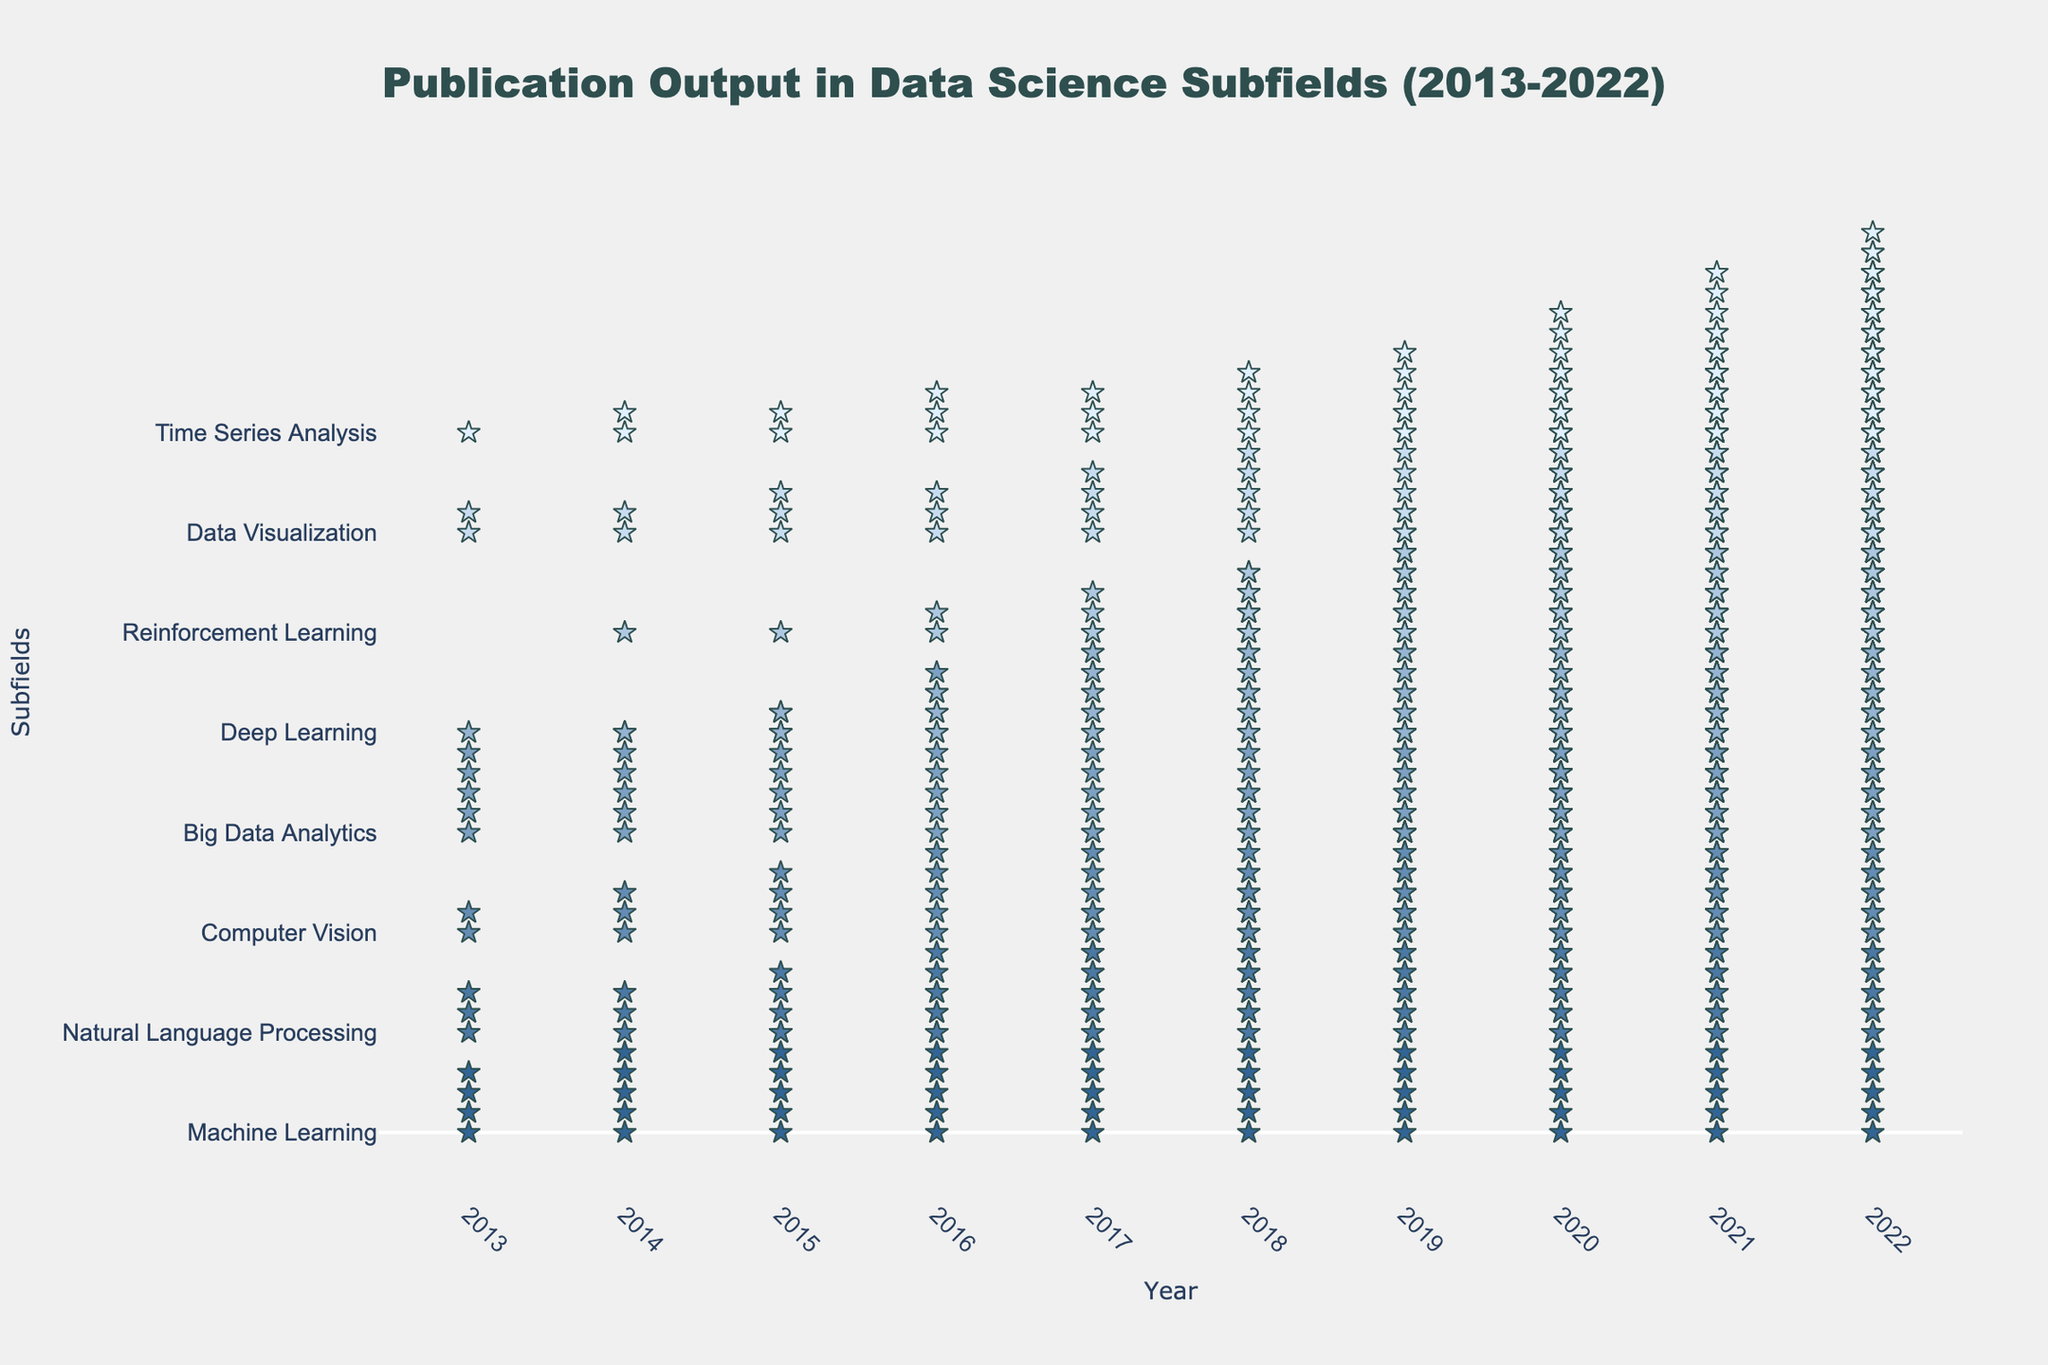What year had the highest publication output for Machine Learning? The figure shows stars representing the number of publications each year. Machine Learning has the most stars in 2022, indicating the highest number of publications.
Answer: 2022 Between 2018 and 2020, which subfield had the largest increase in publication output? By counting the stars for each subfield between 2018 and 2020, we see that Deep Learning has the highest increase in the number of stars from 35 to 70 publications, a 35 publication increase.
Answer: Deep Learning Which subfield had more publications in 2017: Natural Language Processing or Computer Vision? In 2017, count the stars for both subfields. Natural Language Processing has 7 stars (35 publications), and Computer Vision has 6 stars (32 publications).
Answer: Natural Language Processing What is the total number of subfields represented in the plot? The y-axis lists the subfields. Count each unique name listed on the y-axis.
Answer: 8 Between Big Data Analytics and Machine Learning, which subfield had fewer publications in 2015? Compare the number of stars for both subfields in 2015. Big Data Analytics has 7 stars (35 publications), and Machine Learning has 6 stars (30 publications).
Answer: Machine Learning Which subfield shows the steepest growth in publication output over the first 3 years (2013-2015)? Calculate the difference in the number of stars from 2013 to 2015 for each subfield. Machine Learning increases from 20 to 30 (10 publications), which is the steepest growth.
Answer: Machine Learning In 2022, how many more publications did Deep Learning have compared to Time Series Analysis? Compare the number of stars for both subfields in 2022. Deep Learning has 25 stars (125 publications), and Time Series Analysis has 11 stars (55 publications). The difference is 70 publications.
Answer: 70 Which year had the highest publication output overall across all subfields? Summarize star counts across all subfields for each year. 2022 has the most stars collectively.
Answer: 2022 